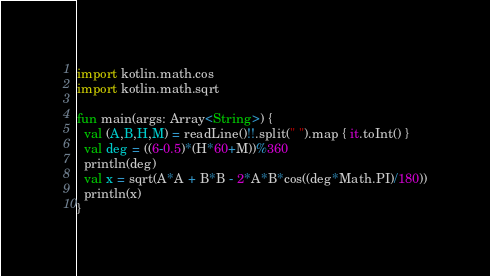<code> <loc_0><loc_0><loc_500><loc_500><_Kotlin_>import kotlin.math.cos
import kotlin.math.sqrt

fun main(args: Array<String>) {
  val (A,B,H,M) = readLine()!!.split(" ").map { it.toInt() }
  val deg = ((6-0.5)*(H*60+M))%360
  println(deg)
  val x = sqrt(A*A + B*B - 2*A*B*cos((deg*Math.PI)/180))
  println(x)
}</code> 